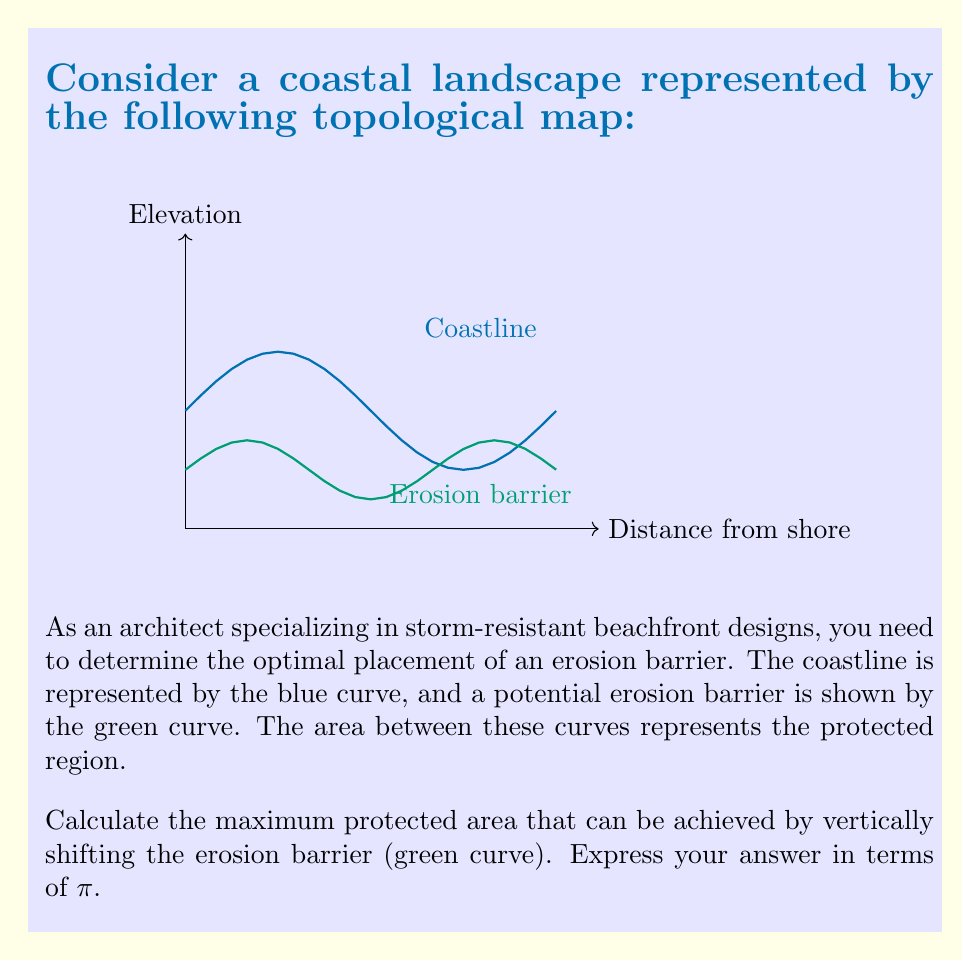Show me your answer to this math problem. To solve this problem, we'll follow these steps:

1) The coastline is represented by the function $f(x) = 0.5\sin(2x) + 1$, and the erosion barrier by $g(x) = 0.25\sin(3x) + 0.5$.

2) The protected area is the area between these curves. We can calculate this using the integral:

   $$A = \int_0^\pi [f(x) - g(x)] dx$$

3) Let's introduce a vertical shift parameter $h$ for the erosion barrier:

   $$A(h) = \int_0^\pi [(0.5\sin(2x) + 1) - (0.25\sin(3x) + 0.5 + h)] dx$$

4) Simplify:

   $$A(h) = \int_0^\pi [0.5\sin(2x) - 0.25\sin(3x) + 0.5 - h] dx$$

5) Integrate each term:

   $$A(h) = [-0.25\cos(2x) + \frac{1}{12}\cos(3x) + 0.5x - hx]_0^\pi$$

6) Evaluate the integral:

   $$A(h) = [-0.25\cos(2\pi) + \frac{1}{12}\cos(3\pi) + 0.5\pi - h\pi] - [-0.25 + \frac{1}{12} + 0]$$
   $$A(h) = [-0.25 + \frac{1}{12} + 0.5\pi - h\pi] - [-0.25 + \frac{1}{12}]$$
   $$A(h) = 0.5\pi - h\pi = \pi(0.5 - h)$$

7) To maximize $A(h)$, we need to choose the largest possible $h$ while ensuring the erosion barrier stays below the coastline at all points.

8) The maximum vertical distance between the curves occurs at the peaks of the coastline, where $\sin(2x) = 1$. At these points:

   $$f(x) = 0.5 + 1 = 1.5$$
   $$g(x) = 0.25\sin(3x) + 0.5 \geq 0.25$$

9) The maximum allowable shift is therefore:

   $$h_{max} = 1.5 - 0.25 = 1.25$$

10) The maximum protected area is:

    $$A_{max} = \pi(0.5 - (-1.25)) = 1.75\pi$$
Answer: $1.75\pi$ 